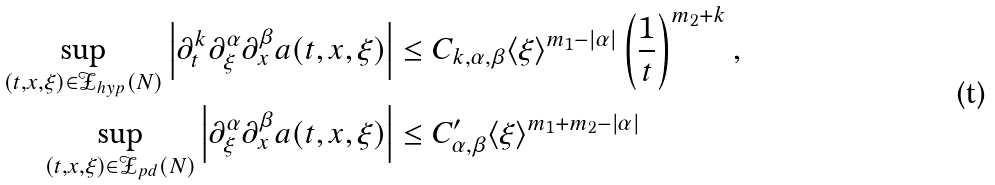<formula> <loc_0><loc_0><loc_500><loc_500>\sup _ { ( t , x , \xi ) \in \mathcal { Z } _ { h y p } ( N ) } \left | \partial _ { t } ^ { k } \partial _ { \xi } ^ { \alpha } \partial _ { x } ^ { \beta } a ( t , x , \xi ) \right | & \leq C _ { k , \alpha , \beta } \langle \xi \rangle ^ { m _ { 1 } - | \alpha | } \left ( \frac { 1 } { t } \right ) ^ { m _ { 2 } + k } , \\ \sup _ { ( t , x , \xi ) \in \mathcal { Z } _ { p d } ( N ) } \left | \partial _ { \xi } ^ { \alpha } \partial _ { x } ^ { \beta } a ( t , x , \xi ) \right | & \leq C ^ { \prime } _ { \alpha , \beta } \langle \xi \rangle ^ { m _ { 1 } + m _ { 2 } - | \alpha | }</formula> 